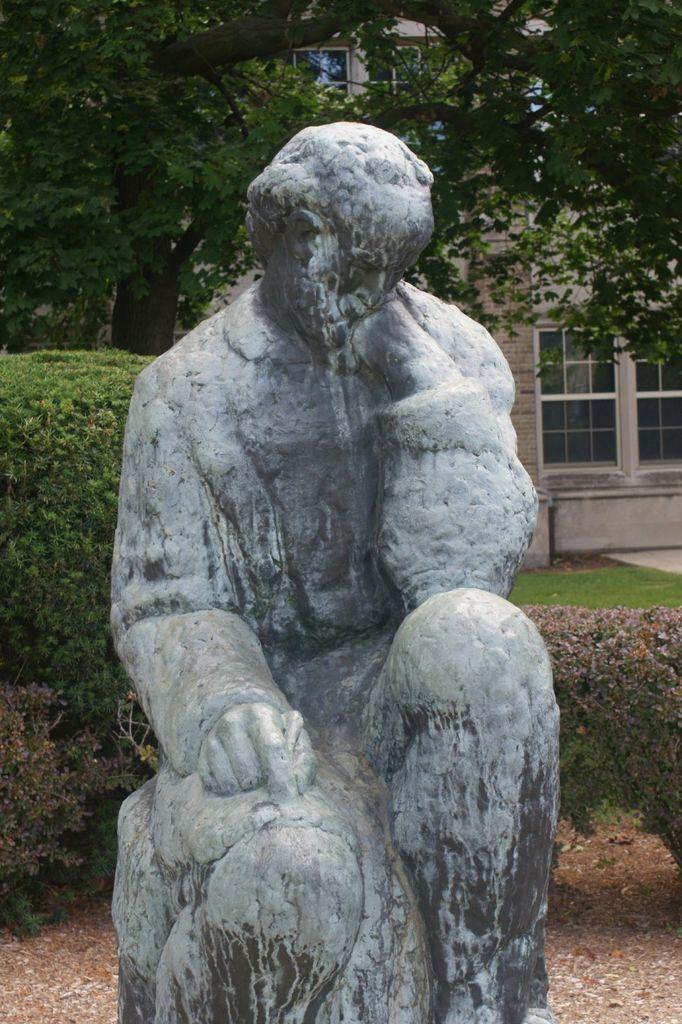What is the main subject of the image? There is a sculpture in the image. What can be seen in the background of the image? There are plants, trees, and a building in the background of the image. What type of powder is being used to create the sculpture in the image? There is no powder visible in the image, and the sculpture appears to be made of a solid material. Is there a canvas present in the image? There is no canvas visible in the image; the sculpture is the main subject. 